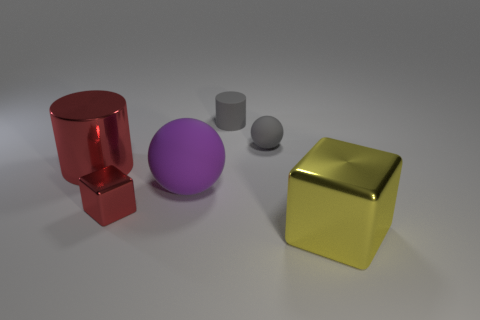Are there any signs of wear or imperfections on the surfaces of these objects? From this viewpoint, the objects seem to be in pristine condition without any noticeable signs of wear, scratches, or imperfections. The impeccable surfaces suggest they are either new or well-maintained. What might be the purpose of arranging these objects like this? Are they meant to represent something? The arrangement could be for a variety of purposes, such as a visual study of geometry, color, and light in photography, or as part of a product showcase. It doesn't seem to represent anything specific beyond a thoughtful composition of shapes and materials. 